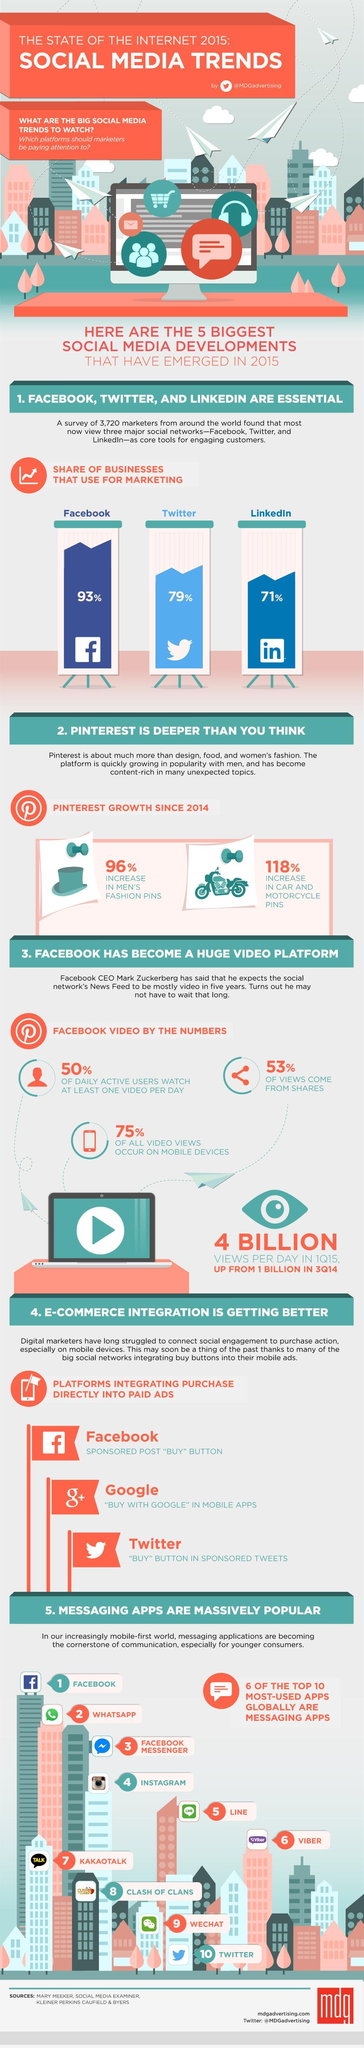What is the total percentage growth of Pinterest in men's fashion and car and motorcycle?
Answer the question with a short phrase. 214% What percentage of all video views occur not from mobile devices? 25% What percentage of views not come from shares? 47% 